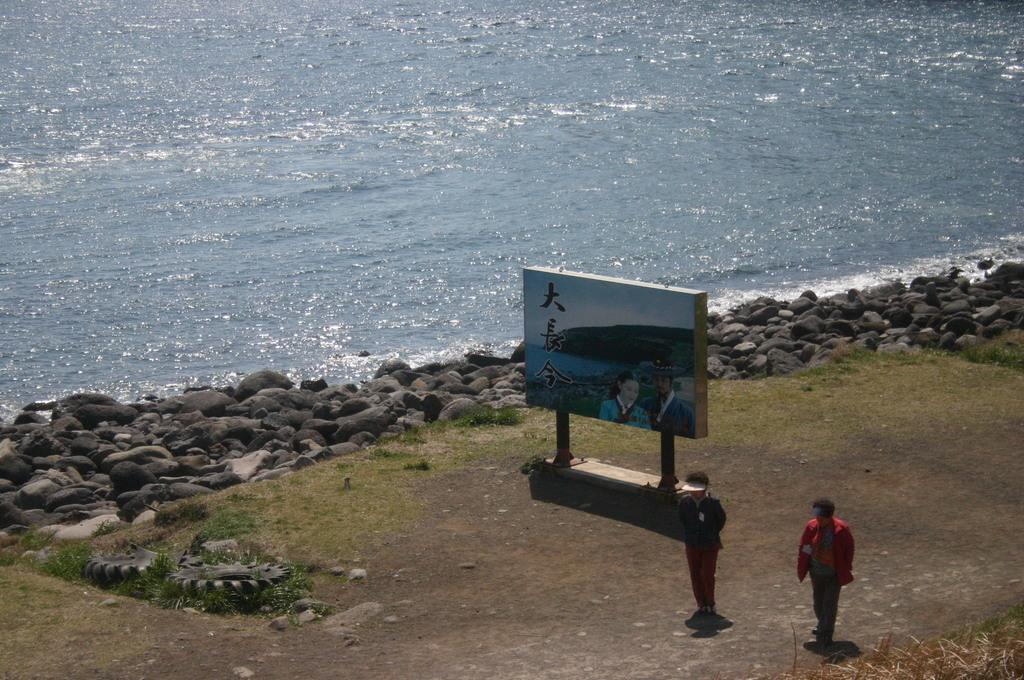How many people are present in the image? There are two people standing in the image. What can be seen on the board in the image? There is text and an image on the board in the image. What type of natural elements are visible in the background of the image? There are stones and water visible in the background of the image. What type of sail can be seen on the plough in the image? There is no sail or plough present in the image. 